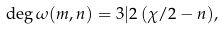<formula> <loc_0><loc_0><loc_500><loc_500>\deg \omega ( m , n ) = 3 | 2 \, ( \chi / 2 - n ) ,</formula> 